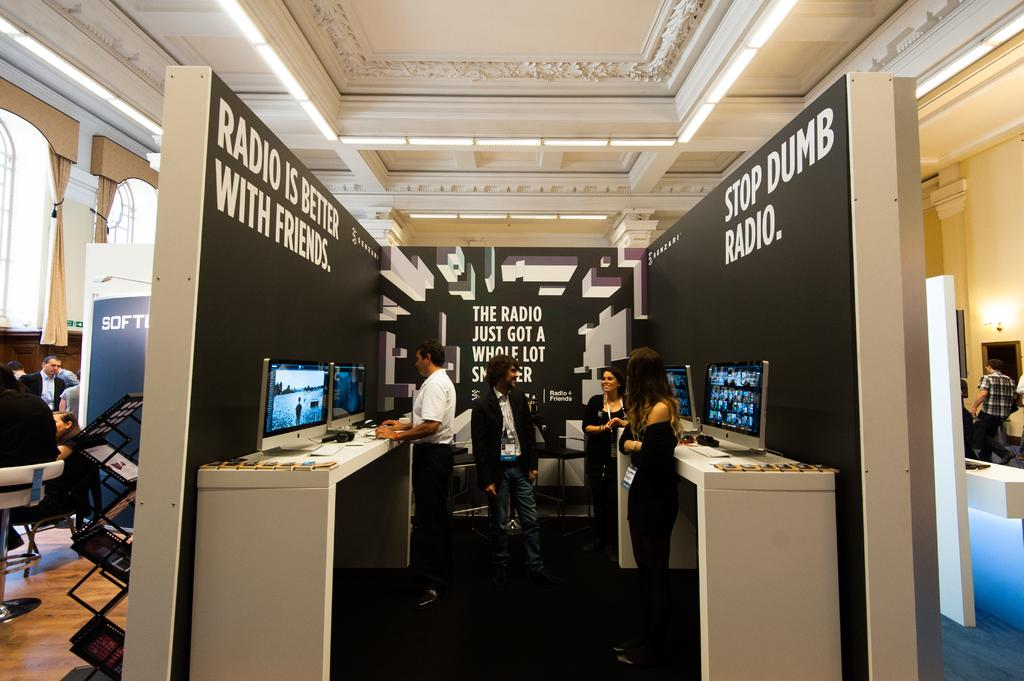Who or what can be seen in the image? There are people in the image. What objects are present in the image that might be used for sitting or eating? There are tables in the image. What electronic devices are visible in the image? There are laptops in the image. What type of surface can be seen in the image that might be used for writing or displaying information? There are boards in the image. What architectural feature is present in the image that might provide structure or separation? There is a wall in the image. What type of brush is being used to clean the laptops in the image? There is no brush visible in the image, and the laptops are not being cleaned. 